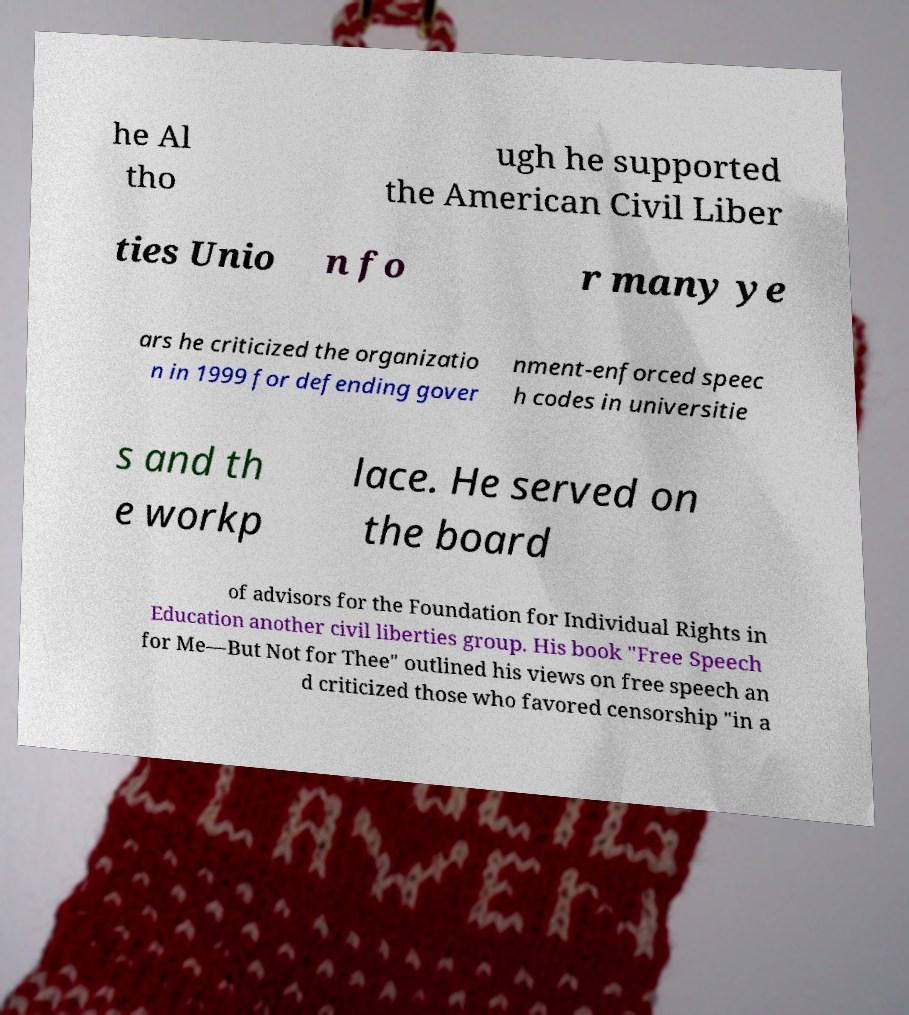For documentation purposes, I need the text within this image transcribed. Could you provide that? he Al tho ugh he supported the American Civil Liber ties Unio n fo r many ye ars he criticized the organizatio n in 1999 for defending gover nment-enforced speec h codes in universitie s and th e workp lace. He served on the board of advisors for the Foundation for Individual Rights in Education another civil liberties group. His book "Free Speech for Me—But Not for Thee" outlined his views on free speech an d criticized those who favored censorship "in a 